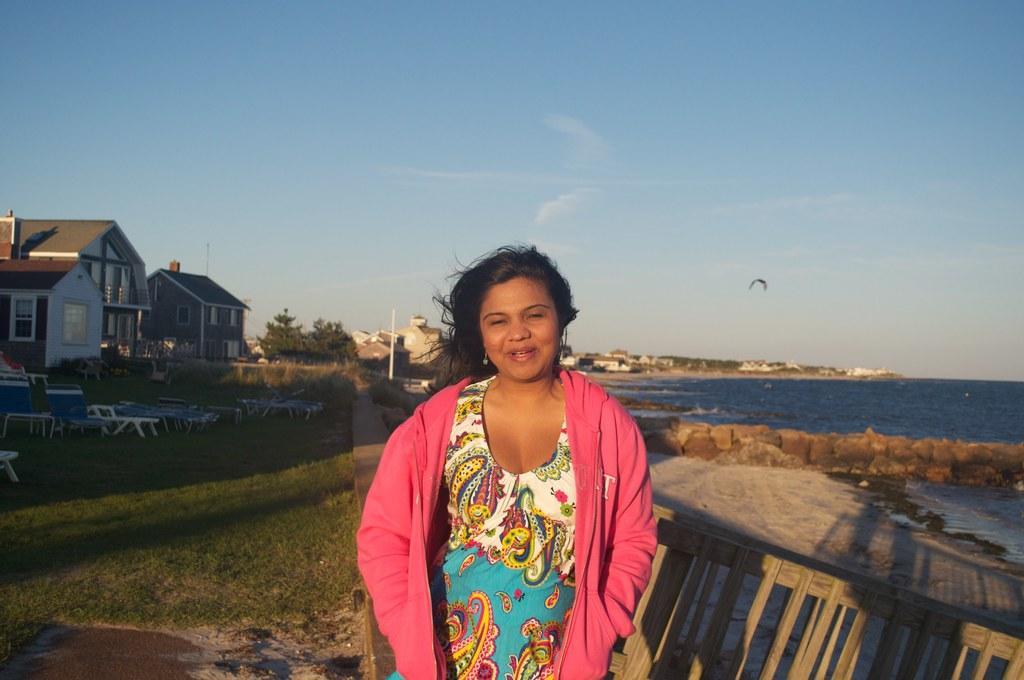How would you summarize this image in a sentence or two? In this picture there is a woman standing. At the back there are buildings and trees and poles. On the left side of the image there are chairs. At the top there is sky and there are clouds and there is a bird flying. In the bottom there is water. On the right side of the image there is a railing. 